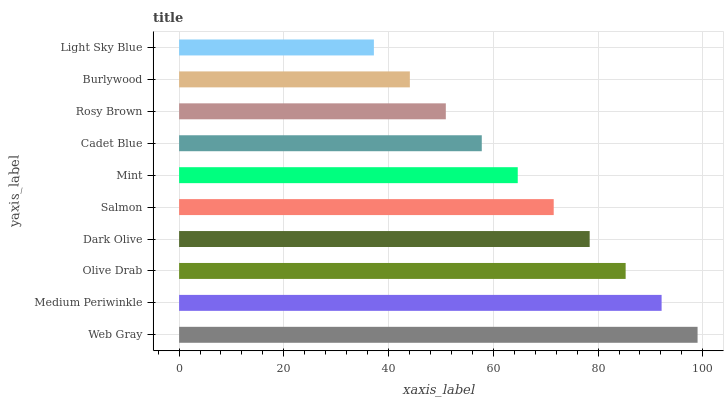Is Light Sky Blue the minimum?
Answer yes or no. Yes. Is Web Gray the maximum?
Answer yes or no. Yes. Is Medium Periwinkle the minimum?
Answer yes or no. No. Is Medium Periwinkle the maximum?
Answer yes or no. No. Is Web Gray greater than Medium Periwinkle?
Answer yes or no. Yes. Is Medium Periwinkle less than Web Gray?
Answer yes or no. Yes. Is Medium Periwinkle greater than Web Gray?
Answer yes or no. No. Is Web Gray less than Medium Periwinkle?
Answer yes or no. No. Is Salmon the high median?
Answer yes or no. Yes. Is Mint the low median?
Answer yes or no. Yes. Is Dark Olive the high median?
Answer yes or no. No. Is Dark Olive the low median?
Answer yes or no. No. 